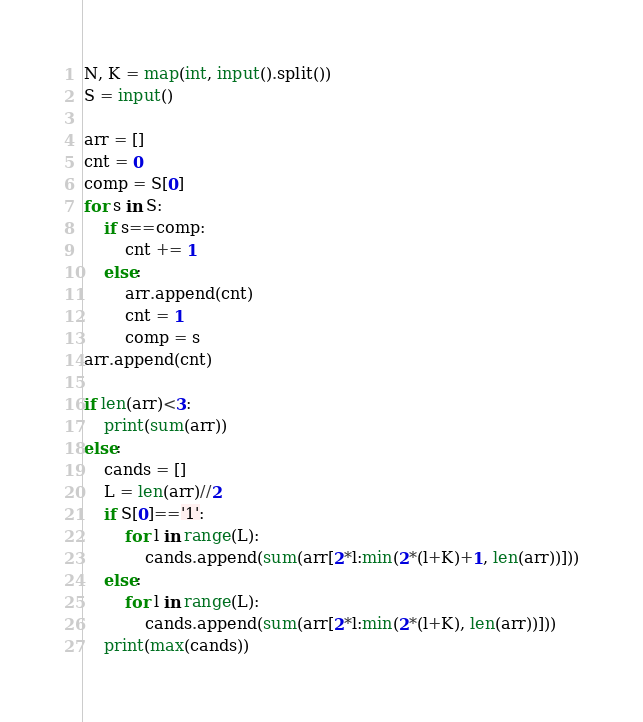Convert code to text. <code><loc_0><loc_0><loc_500><loc_500><_Python_>N, K = map(int, input().split())
S = input()

arr = []
cnt = 0
comp = S[0]
for s in S:
    if s==comp:
        cnt += 1
    else:
        arr.append(cnt)
        cnt = 1
        comp = s
arr.append(cnt)

if len(arr)<3:
    print(sum(arr))
else:
    cands = []
    L = len(arr)//2
    if S[0]=='1':
        for l in range(L):
            cands.append(sum(arr[2*l:min(2*(l+K)+1, len(arr))]))
    else:
        for l in range(L):
            cands.append(sum(arr[2*l:min(2*(l+K), len(arr))]))
    print(max(cands))</code> 